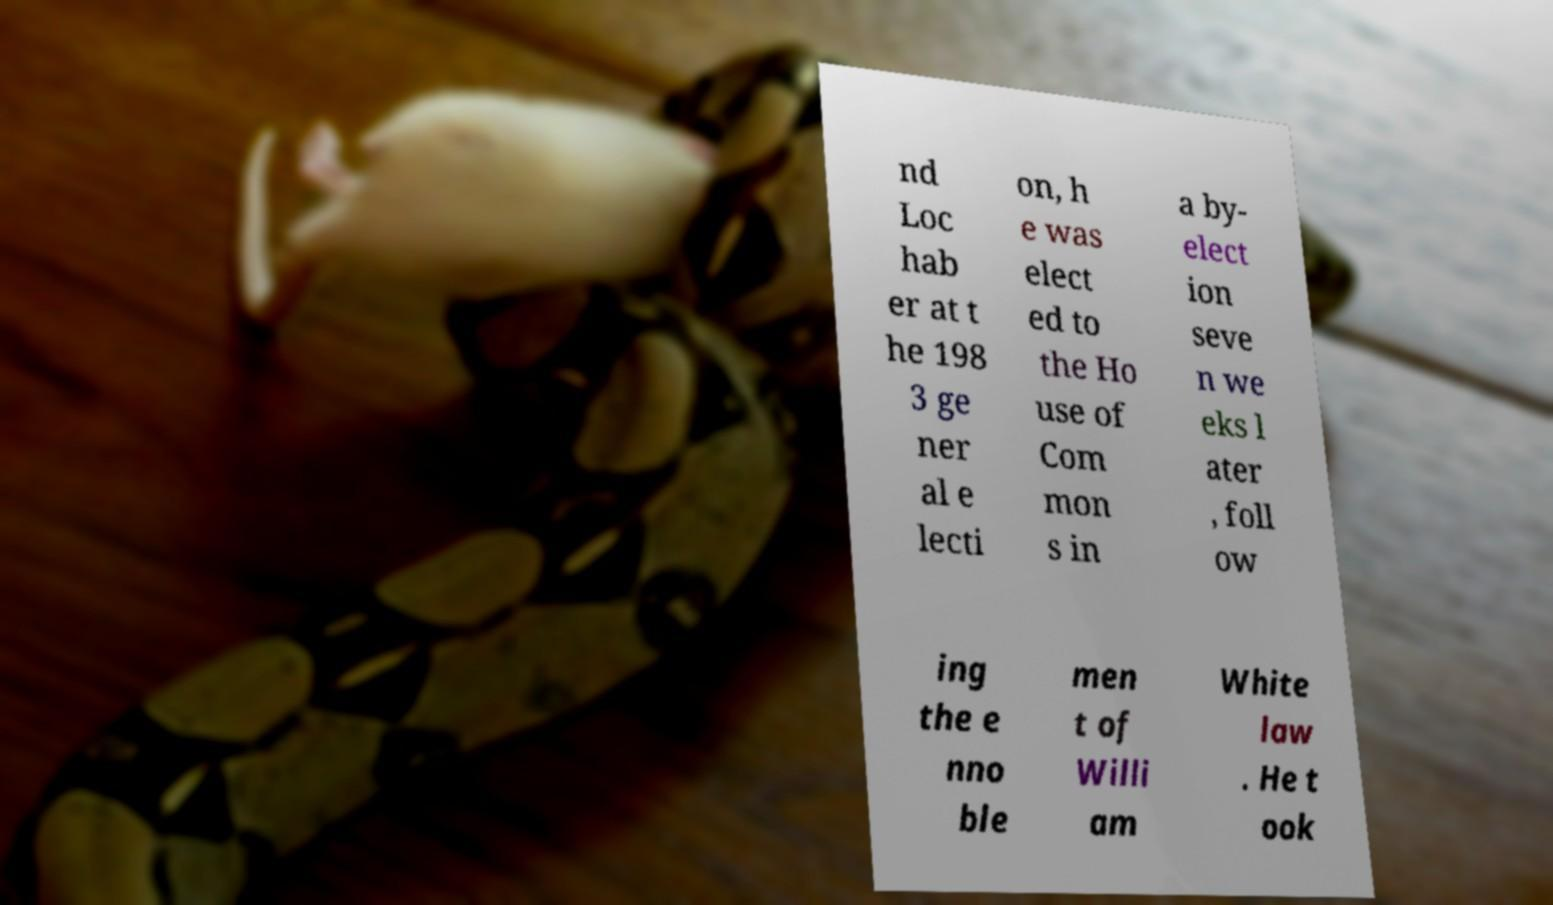Please read and relay the text visible in this image. What does it say? nd Loc hab er at t he 198 3 ge ner al e lecti on, h e was elect ed to the Ho use of Com mon s in a by- elect ion seve n we eks l ater , foll ow ing the e nno ble men t of Willi am White law . He t ook 